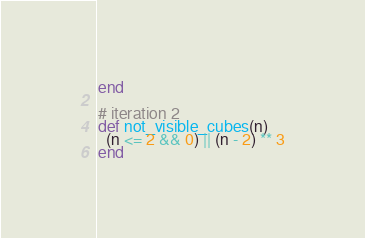<code> <loc_0><loc_0><loc_500><loc_500><_Ruby_>end

# iteration 2
def not_visible_cubes(n)
  (n <= 2 && 0) || (n - 2) ** 3
end
</code> 